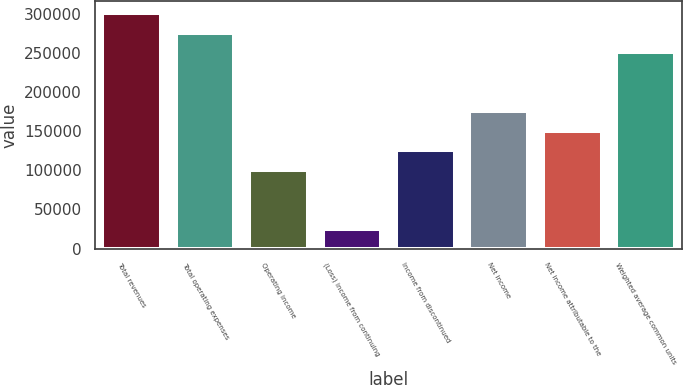Convert chart to OTSL. <chart><loc_0><loc_0><loc_500><loc_500><bar_chart><fcel>Total revenues<fcel>Total operating expenses<fcel>Operating income<fcel>(Loss) income from continuing<fcel>Income from discontinued<fcel>Net income<fcel>Net income attributable to the<fcel>Weighted average common units<nl><fcel>301034<fcel>275948<fcel>100345<fcel>25086.2<fcel>125431<fcel>175603<fcel>150517<fcel>250862<nl></chart> 